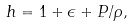Convert formula to latex. <formula><loc_0><loc_0><loc_500><loc_500>h = 1 + \epsilon + P / \rho ,</formula> 